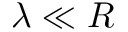<formula> <loc_0><loc_0><loc_500><loc_500>\lambda \ll R</formula> 